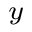Convert formula to latex. <formula><loc_0><loc_0><loc_500><loc_500>_ { y }</formula> 